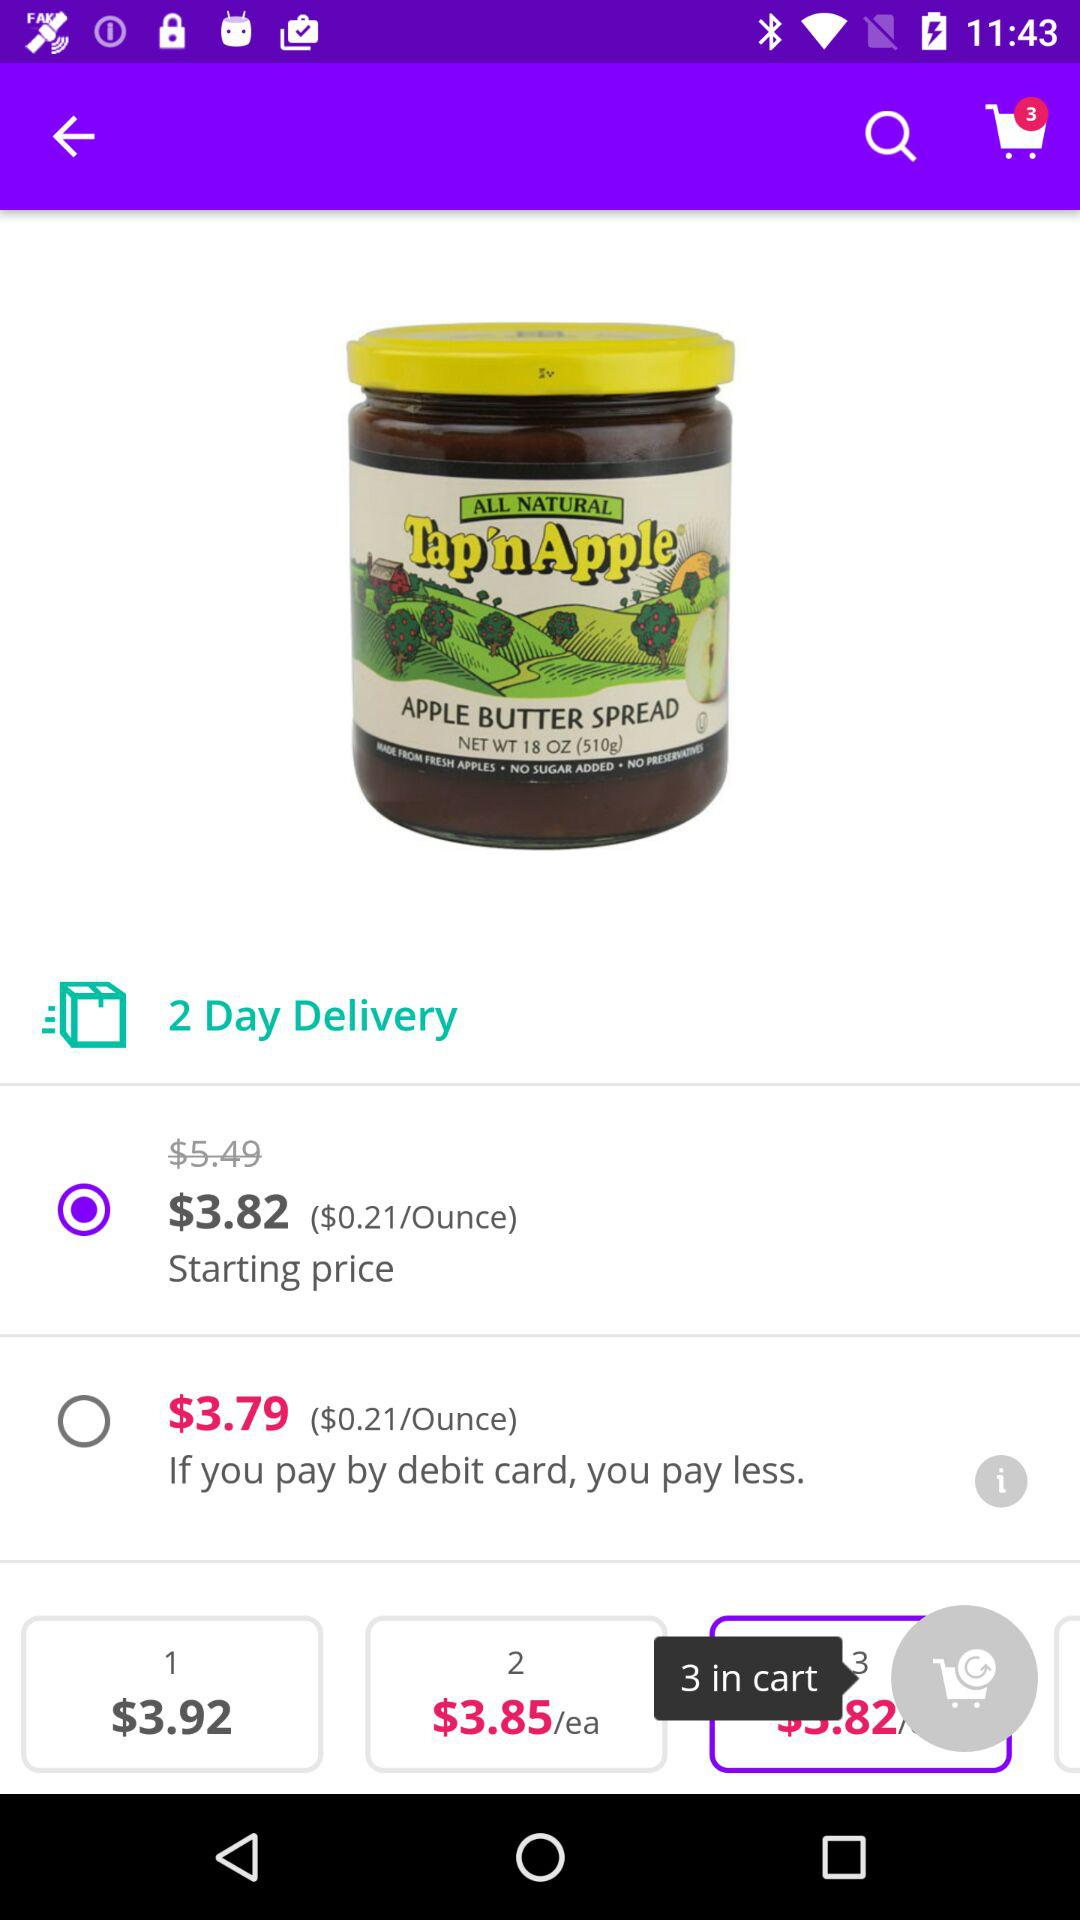How many items are in the cart? There are 3 items in the cart. 